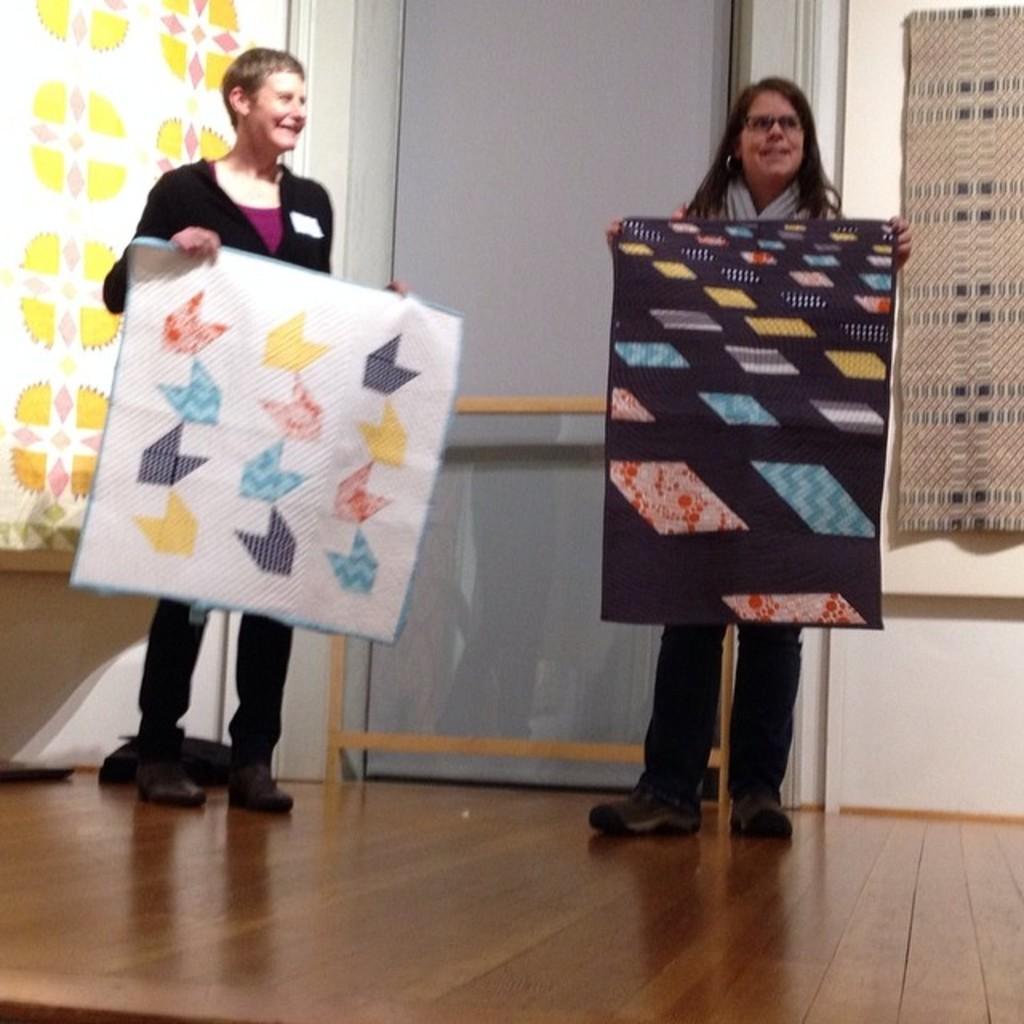How would you summarize this image in a sentence or two? On the left side a woman is standing, she wore a black color dress and also holding a white color cloth in her hands. On the right side another woman is standing. 